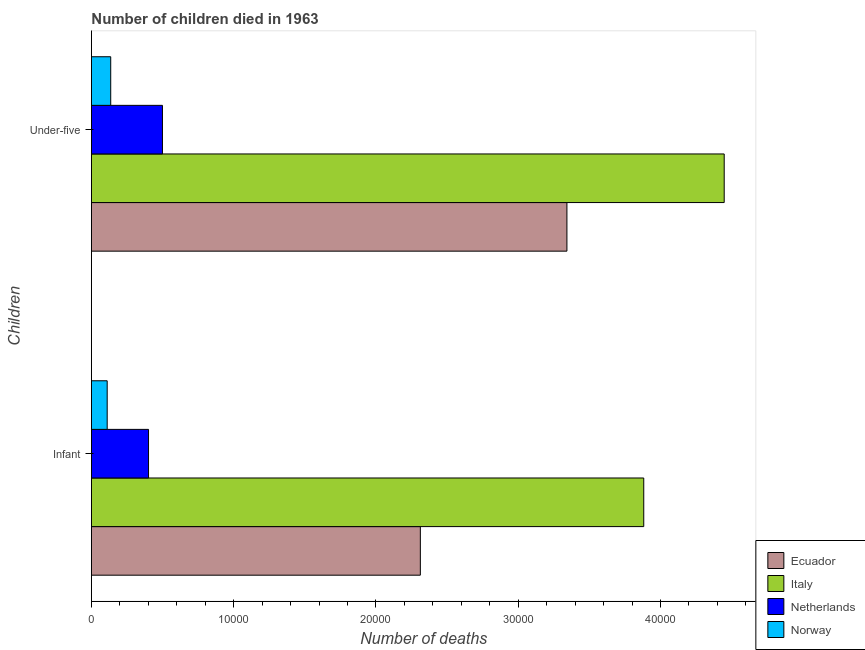How many different coloured bars are there?
Keep it short and to the point. 4. Are the number of bars per tick equal to the number of legend labels?
Offer a very short reply. Yes. Are the number of bars on each tick of the Y-axis equal?
Your answer should be very brief. Yes. What is the label of the 2nd group of bars from the top?
Offer a very short reply. Infant. What is the number of infant deaths in Norway?
Your answer should be very brief. 1108. Across all countries, what is the maximum number of infant deaths?
Provide a succinct answer. 3.88e+04. Across all countries, what is the minimum number of under-five deaths?
Offer a very short reply. 1356. In which country was the number of infant deaths maximum?
Your response must be concise. Italy. In which country was the number of under-five deaths minimum?
Your response must be concise. Norway. What is the total number of infant deaths in the graph?
Provide a short and direct response. 6.71e+04. What is the difference between the number of infant deaths in Ecuador and that in Italy?
Your answer should be compact. -1.57e+04. What is the difference between the number of under-five deaths in Norway and the number of infant deaths in Netherlands?
Make the answer very short. -2658. What is the average number of under-five deaths per country?
Your answer should be very brief. 2.11e+04. What is the difference between the number of infant deaths and number of under-five deaths in Italy?
Your answer should be compact. -5655. In how many countries, is the number of under-five deaths greater than 38000 ?
Make the answer very short. 1. What is the ratio of the number of infant deaths in Italy to that in Norway?
Ensure brevity in your answer.  35.04. What does the 4th bar from the top in Under-five represents?
Offer a terse response. Ecuador. What does the 1st bar from the bottom in Under-five represents?
Make the answer very short. Ecuador. How many bars are there?
Make the answer very short. 8. Are all the bars in the graph horizontal?
Keep it short and to the point. Yes. How many countries are there in the graph?
Your answer should be very brief. 4. What is the difference between two consecutive major ticks on the X-axis?
Make the answer very short. 10000. Are the values on the major ticks of X-axis written in scientific E-notation?
Your answer should be very brief. No. Does the graph contain any zero values?
Your response must be concise. No. Does the graph contain grids?
Your response must be concise. No. Where does the legend appear in the graph?
Ensure brevity in your answer.  Bottom right. How many legend labels are there?
Your answer should be very brief. 4. What is the title of the graph?
Give a very brief answer. Number of children died in 1963. What is the label or title of the X-axis?
Make the answer very short. Number of deaths. What is the label or title of the Y-axis?
Offer a terse response. Children. What is the Number of deaths in Ecuador in Infant?
Your answer should be compact. 2.31e+04. What is the Number of deaths in Italy in Infant?
Give a very brief answer. 3.88e+04. What is the Number of deaths in Netherlands in Infant?
Give a very brief answer. 4014. What is the Number of deaths in Norway in Infant?
Give a very brief answer. 1108. What is the Number of deaths of Ecuador in Under-five?
Provide a short and direct response. 3.34e+04. What is the Number of deaths in Italy in Under-five?
Provide a short and direct response. 4.45e+04. What is the Number of deaths of Netherlands in Under-five?
Ensure brevity in your answer.  4993. What is the Number of deaths of Norway in Under-five?
Offer a very short reply. 1356. Across all Children, what is the maximum Number of deaths in Ecuador?
Your response must be concise. 3.34e+04. Across all Children, what is the maximum Number of deaths in Italy?
Keep it short and to the point. 4.45e+04. Across all Children, what is the maximum Number of deaths of Netherlands?
Your answer should be compact. 4993. Across all Children, what is the maximum Number of deaths in Norway?
Offer a very short reply. 1356. Across all Children, what is the minimum Number of deaths of Ecuador?
Offer a terse response. 2.31e+04. Across all Children, what is the minimum Number of deaths in Italy?
Your response must be concise. 3.88e+04. Across all Children, what is the minimum Number of deaths in Netherlands?
Make the answer very short. 4014. Across all Children, what is the minimum Number of deaths in Norway?
Make the answer very short. 1108. What is the total Number of deaths in Ecuador in the graph?
Ensure brevity in your answer.  5.65e+04. What is the total Number of deaths in Italy in the graph?
Your answer should be compact. 8.33e+04. What is the total Number of deaths in Netherlands in the graph?
Keep it short and to the point. 9007. What is the total Number of deaths of Norway in the graph?
Ensure brevity in your answer.  2464. What is the difference between the Number of deaths of Ecuador in Infant and that in Under-five?
Your answer should be compact. -1.03e+04. What is the difference between the Number of deaths in Italy in Infant and that in Under-five?
Make the answer very short. -5655. What is the difference between the Number of deaths of Netherlands in Infant and that in Under-five?
Provide a succinct answer. -979. What is the difference between the Number of deaths of Norway in Infant and that in Under-five?
Your response must be concise. -248. What is the difference between the Number of deaths of Ecuador in Infant and the Number of deaths of Italy in Under-five?
Provide a short and direct response. -2.14e+04. What is the difference between the Number of deaths of Ecuador in Infant and the Number of deaths of Netherlands in Under-five?
Offer a terse response. 1.81e+04. What is the difference between the Number of deaths in Ecuador in Infant and the Number of deaths in Norway in Under-five?
Provide a succinct answer. 2.18e+04. What is the difference between the Number of deaths in Italy in Infant and the Number of deaths in Netherlands in Under-five?
Give a very brief answer. 3.38e+04. What is the difference between the Number of deaths of Italy in Infant and the Number of deaths of Norway in Under-five?
Offer a very short reply. 3.75e+04. What is the difference between the Number of deaths in Netherlands in Infant and the Number of deaths in Norway in Under-five?
Make the answer very short. 2658. What is the average Number of deaths in Ecuador per Children?
Ensure brevity in your answer.  2.83e+04. What is the average Number of deaths in Italy per Children?
Keep it short and to the point. 4.17e+04. What is the average Number of deaths in Netherlands per Children?
Make the answer very short. 4503.5. What is the average Number of deaths of Norway per Children?
Ensure brevity in your answer.  1232. What is the difference between the Number of deaths in Ecuador and Number of deaths in Italy in Infant?
Your answer should be very brief. -1.57e+04. What is the difference between the Number of deaths in Ecuador and Number of deaths in Netherlands in Infant?
Your answer should be compact. 1.91e+04. What is the difference between the Number of deaths of Ecuador and Number of deaths of Norway in Infant?
Your response must be concise. 2.20e+04. What is the difference between the Number of deaths of Italy and Number of deaths of Netherlands in Infant?
Give a very brief answer. 3.48e+04. What is the difference between the Number of deaths in Italy and Number of deaths in Norway in Infant?
Offer a very short reply. 3.77e+04. What is the difference between the Number of deaths in Netherlands and Number of deaths in Norway in Infant?
Give a very brief answer. 2906. What is the difference between the Number of deaths of Ecuador and Number of deaths of Italy in Under-five?
Your answer should be compact. -1.11e+04. What is the difference between the Number of deaths of Ecuador and Number of deaths of Netherlands in Under-five?
Offer a very short reply. 2.84e+04. What is the difference between the Number of deaths of Ecuador and Number of deaths of Norway in Under-five?
Your response must be concise. 3.21e+04. What is the difference between the Number of deaths in Italy and Number of deaths in Netherlands in Under-five?
Offer a terse response. 3.95e+04. What is the difference between the Number of deaths of Italy and Number of deaths of Norway in Under-five?
Your answer should be very brief. 4.31e+04. What is the difference between the Number of deaths of Netherlands and Number of deaths of Norway in Under-five?
Offer a terse response. 3637. What is the ratio of the Number of deaths in Ecuador in Infant to that in Under-five?
Ensure brevity in your answer.  0.69. What is the ratio of the Number of deaths in Italy in Infant to that in Under-five?
Ensure brevity in your answer.  0.87. What is the ratio of the Number of deaths in Netherlands in Infant to that in Under-five?
Your response must be concise. 0.8. What is the ratio of the Number of deaths in Norway in Infant to that in Under-five?
Ensure brevity in your answer.  0.82. What is the difference between the highest and the second highest Number of deaths in Ecuador?
Your answer should be compact. 1.03e+04. What is the difference between the highest and the second highest Number of deaths in Italy?
Offer a terse response. 5655. What is the difference between the highest and the second highest Number of deaths in Netherlands?
Your response must be concise. 979. What is the difference between the highest and the second highest Number of deaths in Norway?
Make the answer very short. 248. What is the difference between the highest and the lowest Number of deaths in Ecuador?
Offer a very short reply. 1.03e+04. What is the difference between the highest and the lowest Number of deaths of Italy?
Offer a terse response. 5655. What is the difference between the highest and the lowest Number of deaths of Netherlands?
Your response must be concise. 979. What is the difference between the highest and the lowest Number of deaths of Norway?
Offer a very short reply. 248. 